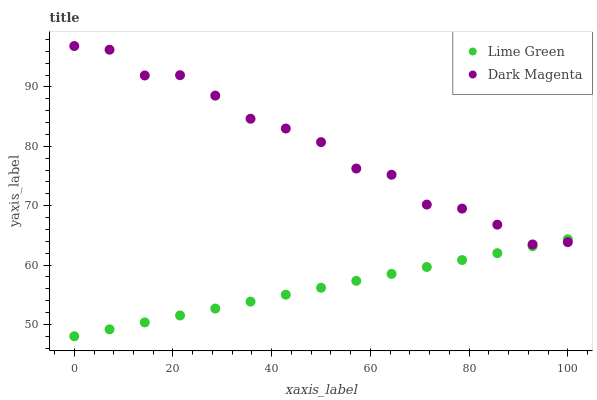Does Lime Green have the minimum area under the curve?
Answer yes or no. Yes. Does Dark Magenta have the maximum area under the curve?
Answer yes or no. Yes. Does Dark Magenta have the minimum area under the curve?
Answer yes or no. No. Is Lime Green the smoothest?
Answer yes or no. Yes. Is Dark Magenta the roughest?
Answer yes or no. Yes. Is Dark Magenta the smoothest?
Answer yes or no. No. Does Lime Green have the lowest value?
Answer yes or no. Yes. Does Dark Magenta have the lowest value?
Answer yes or no. No. Does Dark Magenta have the highest value?
Answer yes or no. Yes. Does Dark Magenta intersect Lime Green?
Answer yes or no. Yes. Is Dark Magenta less than Lime Green?
Answer yes or no. No. Is Dark Magenta greater than Lime Green?
Answer yes or no. No. 